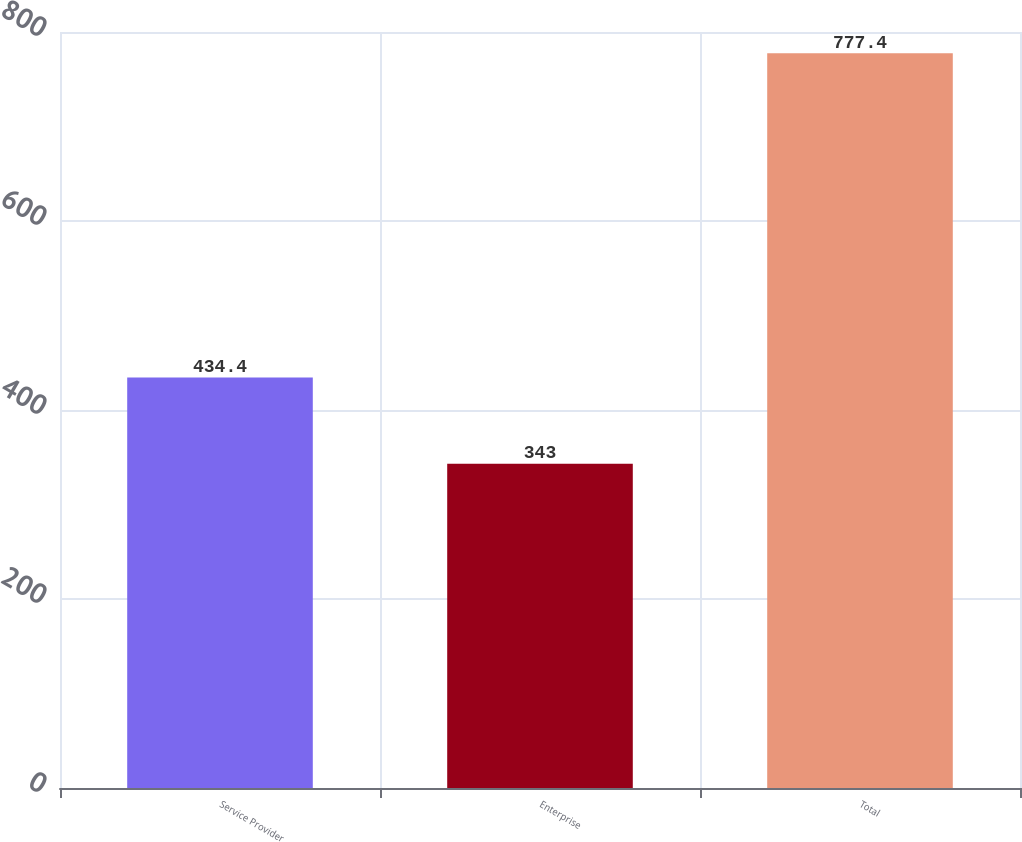<chart> <loc_0><loc_0><loc_500><loc_500><bar_chart><fcel>Service Provider<fcel>Enterprise<fcel>Total<nl><fcel>434.4<fcel>343<fcel>777.4<nl></chart> 